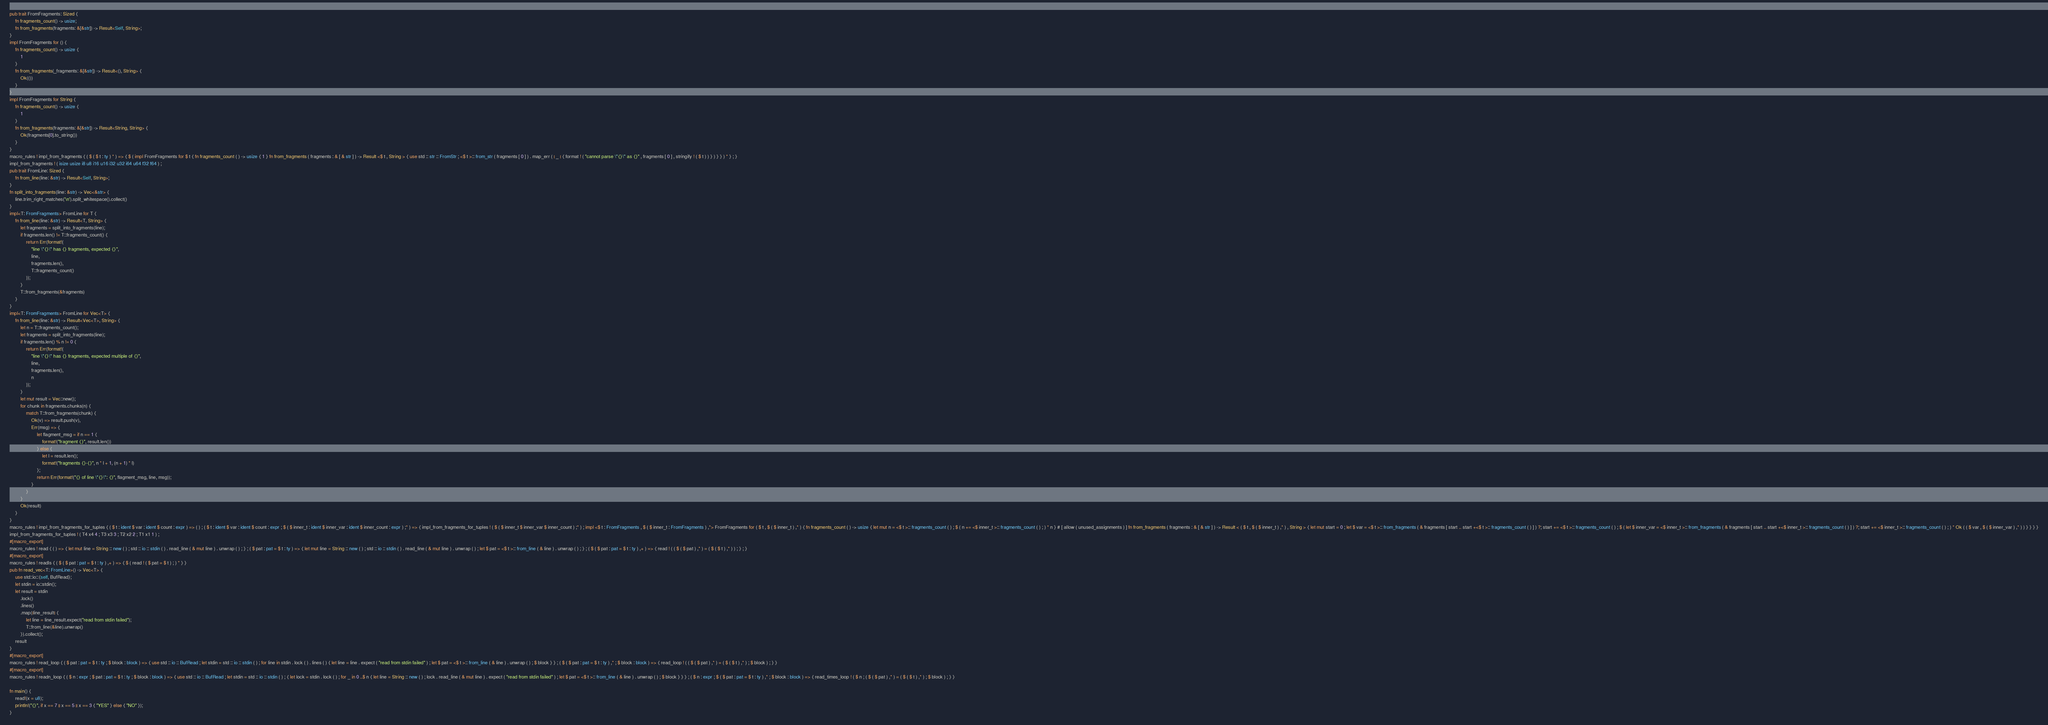<code> <loc_0><loc_0><loc_500><loc_500><_Rust_>pub trait FromFragments: Sized {
    fn fragments_count() -> usize;
    fn from_fragments(fragments: &[&str]) -> Result<Self, String>;
}
impl FromFragments for () {
    fn fragments_count() -> usize {
        1
    }
    fn from_fragments(_fragments: &[&str]) -> Result<(), String> {
        Ok(())
    }
}
impl FromFragments for String {
    fn fragments_count() -> usize {
        1
    }
    fn from_fragments(fragments: &[&str]) -> Result<String, String> {
        Ok(fragments[0].to_string())
    }
}
macro_rules ! impl_from_fragments { ( $ ( $ t : ty ) * ) => { $ ( impl FromFragments for $ t { fn fragments_count ( ) -> usize { 1 } fn from_fragments ( fragments : & [ & str ] ) -> Result <$ t , String > { use std :: str :: FromStr ; <$ t >:: from_str ( fragments [ 0 ] ) . map_err ( | _ | { format ! ( "cannot parse \"{}\" as {}" , fragments [ 0 ] , stringify ! ( $ t ) ) } ) } } ) * } ; }
impl_from_fragments ! ( isize usize i8 u8 i16 u16 i32 u32 i64 u64 f32 f64 ) ;
pub trait FromLine: Sized {
    fn from_line(line: &str) -> Result<Self, String>;
}
fn split_into_fragments(line: &str) -> Vec<&str> {
    line.trim_right_matches('\n').split_whitespace().collect()
}
impl<T: FromFragments> FromLine for T {
    fn from_line(line: &str) -> Result<T, String> {
        let fragments = split_into_fragments(line);
        if fragments.len() != T::fragments_count() {
            return Err(format!(
                "line \"{}\" has {} fragments, expected {}",
                line,
                fragments.len(),
                T::fragments_count()
            ));
        }
        T::from_fragments(&fragments)
    }
}
impl<T: FromFragments> FromLine for Vec<T> {
    fn from_line(line: &str) -> Result<Vec<T>, String> {
        let n = T::fragments_count();
        let fragments = split_into_fragments(line);
        if fragments.len() % n != 0 {
            return Err(format!(
                "line \"{}\" has {} fragments, expected multiple of {}",
                line,
                fragments.len(),
                n
            ));
        }
        let mut result = Vec::new();
        for chunk in fragments.chunks(n) {
            match T::from_fragments(chunk) {
                Ok(v) => result.push(v),
                Err(msg) => {
                    let flagment_msg = if n == 1 {
                        format!("fragment {}", result.len())
                    } else {
                        let l = result.len();
                        format!("fragments {}-{}", n * l + 1, (n + 1) * l)
                    };
                    return Err(format!("{} of line \"{}\": {}", flagment_msg, line, msg));
                }
            }
        }
        Ok(result)
    }
}
macro_rules ! impl_from_fragments_for_tuples { ( $ t : ident $ var : ident $ count : expr ) => ( ) ; ( $ t : ident $ var : ident $ count : expr ; $ ( $ inner_t : ident $ inner_var : ident $ inner_count : expr ) ;* ) => { impl_from_fragments_for_tuples ! ( $ ( $ inner_t $ inner_var $ inner_count ) ;* ) ; impl <$ t : FromFragments , $ ( $ inner_t : FromFragments ) ,*> FromFragments for ( $ t , $ ( $ inner_t ) ,* ) { fn fragments_count ( ) -> usize { let mut n = <$ t >:: fragments_count ( ) ; $ ( n += <$ inner_t >:: fragments_count ( ) ; ) * n } # [ allow ( unused_assignments ) ] fn from_fragments ( fragments : & [ & str ] ) -> Result < ( $ t , $ ( $ inner_t ) ,* ) , String > { let mut start = 0 ; let $ var = <$ t >:: from_fragments ( & fragments [ start .. start +<$ t >:: fragments_count ( ) ] ) ?; start += <$ t >:: fragments_count ( ) ; $ ( let $ inner_var = <$ inner_t >:: from_fragments ( & fragments [ start .. start +<$ inner_t >:: fragments_count ( ) ] ) ?; start += <$ inner_t >:: fragments_count ( ) ; ) * Ok ( ( $ var , $ ( $ inner_var ) ,* ) ) } } } }
impl_from_fragments_for_tuples ! ( T4 x4 4 ; T3 x3 3 ; T2 x2 2 ; T1 x1 1 ) ;
#[macro_export]
macro_rules ! read { ( ) => { let mut line = String :: new ( ) ; std :: io :: stdin ( ) . read_line ( & mut line ) . unwrap ( ) ; } ; ( $ pat : pat = $ t : ty ) => { let mut line = String :: new ( ) ; std :: io :: stdin ( ) . read_line ( & mut line ) . unwrap ( ) ; let $ pat = <$ t >:: from_line ( & line ) . unwrap ( ) ; } ; ( $ ( $ pat : pat = $ t : ty ) ,+ ) => { read ! ( ( $ ( $ pat ) ,* ) = ( $ ( $ t ) ,* ) ) ; } ; }
#[macro_export]
macro_rules ! readls { ( $ ( $ pat : pat = $ t : ty ) ,+ ) => { $ ( read ! ( $ pat = $ t ) ; ) * } }
pub fn read_vec<T: FromLine>() -> Vec<T> {
    use std::io::{self, BufRead};
    let stdin = io::stdin();
    let result = stdin
        .lock()
        .lines()
        .map(|line_result| {
            let line = line_result.expect("read from stdin failed");
            T::from_line(&line).unwrap()
        }).collect();
    result
}
#[macro_export]
macro_rules ! read_loop { ( $ pat : pat = $ t : ty ; $ block : block ) => { use std :: io :: BufRead ; let stdin = std :: io :: stdin ( ) ; for line in stdin . lock ( ) . lines ( ) { let line = line . expect ( "read from stdin failed" ) ; let $ pat = <$ t >:: from_line ( & line ) . unwrap ( ) ; $ block } } ; ( $ ( $ pat : pat = $ t : ty ) ,* ; $ block : block ) => { read_loop ! ( ( $ ( $ pat ) ,* ) = ( $ ( $ t ) ,* ) ; $ block ) ; } }
#[macro_export]
macro_rules ! readn_loop { ( $ n : expr ; $ pat : pat = $ t : ty ; $ block : block ) => { use std :: io :: BufRead ; let stdin = std :: io :: stdin ( ) ; { let lock = stdin . lock ( ) ; for _ in 0 ..$ n { let line = String :: new ( ) ; lock . read_line ( & mut line ) . expect ( "read from stdin failed" ) ; let $ pat = <$ t >:: from_line ( & line ) . unwrap ( ) ; $ block } } } ; ( $ n : expr ; $ ( $ pat : pat = $ t : ty ) ,* ; $ block : block ) => { read_times_loop ! ( $ n ; ( $ ( $ pat ) ,* ) = ( $ ( $ t ) ,* ) ; $ block ) ; } }

fn main() {
    read!(x = u8);
    println!("{}", if x == 7 || x == 5 || x == 3 { "YES" } else { "NO" });
}
</code> 